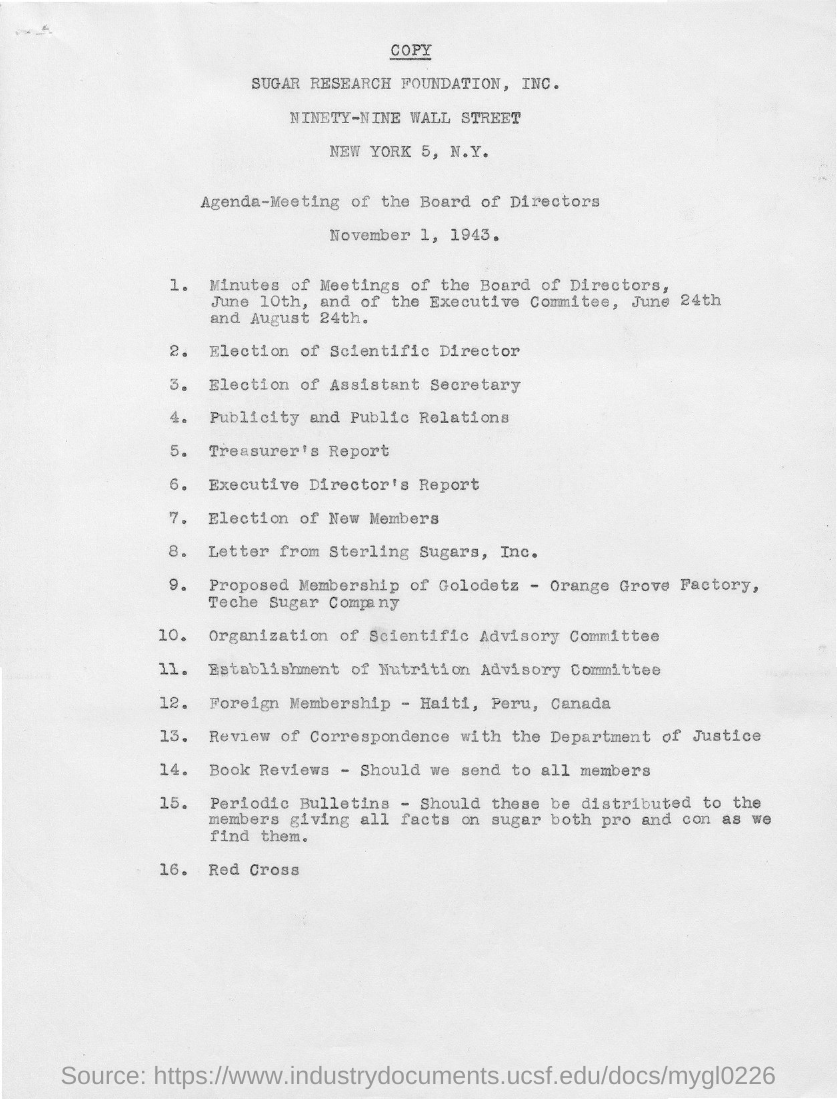What are some of the key issues being addressed in this meeting according to the agenda? The agenda covers several key issues including the election of various positions like the Scientific Director and Assistant Secretary, reviews of financial reports, and strategic discussions on public relations, membership expansion, and scientific advisory matters. 